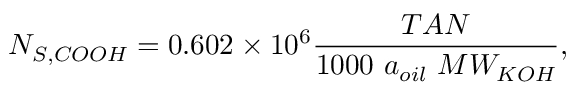<formula> <loc_0><loc_0><loc_500><loc_500>N _ { S , C O O H } = 0 . 6 0 2 \times 1 0 ^ { 6 } \frac { T A N } { 1 0 0 0 a _ { o i l } M W _ { K O H } } ,</formula> 